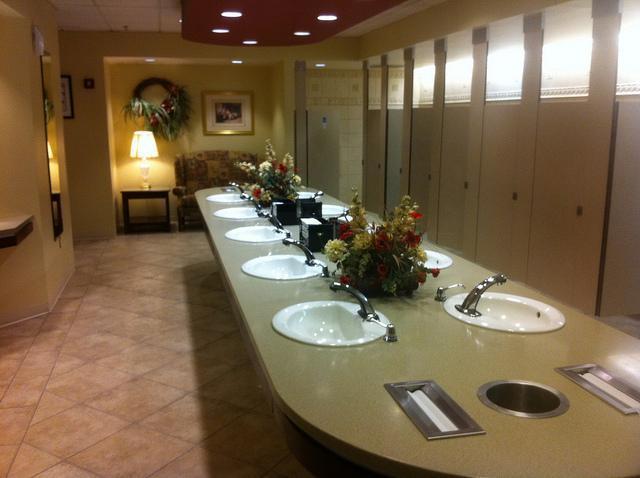How many sinks are in the picture?
Give a very brief answer. 2. How many potted plants are there?
Give a very brief answer. 2. How many of the people in the image are shirtless?
Give a very brief answer. 0. 